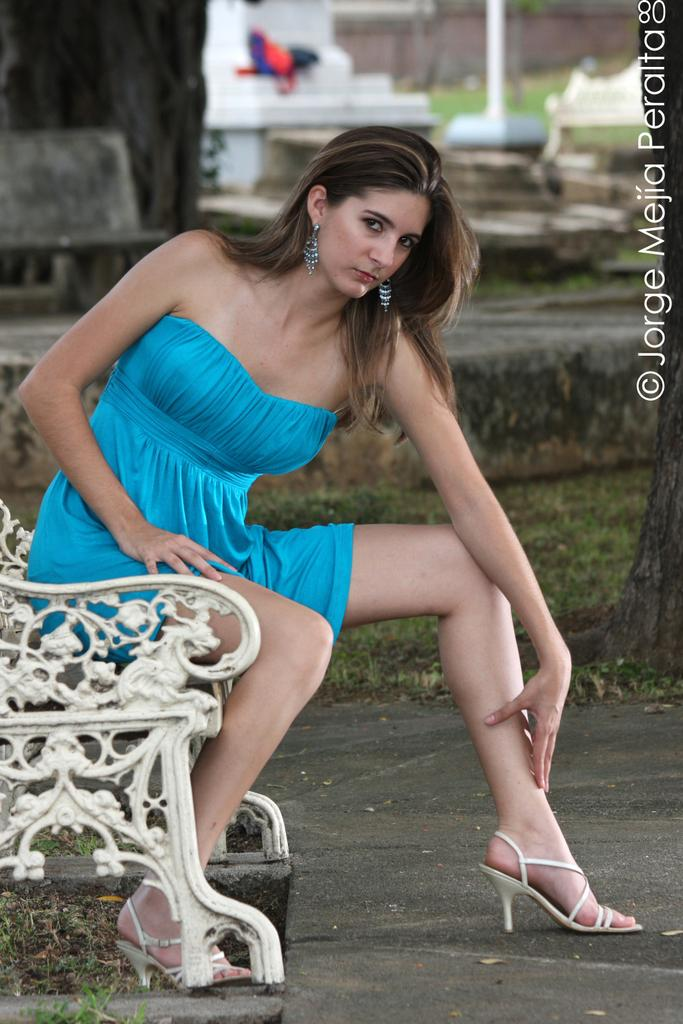Who is the main subject in the image? There is a woman in the image. What is the woman wearing? The woman is wearing a sky blue dress. Where is the woman sitting? The woman is sitting on a bench. What can be seen in the background of the image? There are houses and grass in the background of the image. What type of texture does the birth certificate have in the image? There is no birth certificate present in the image, so it is not possible to determine its texture. 